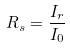Convert formula to latex. <formula><loc_0><loc_0><loc_500><loc_500>R _ { s } = \frac { I _ { r } } { I _ { 0 } }</formula> 